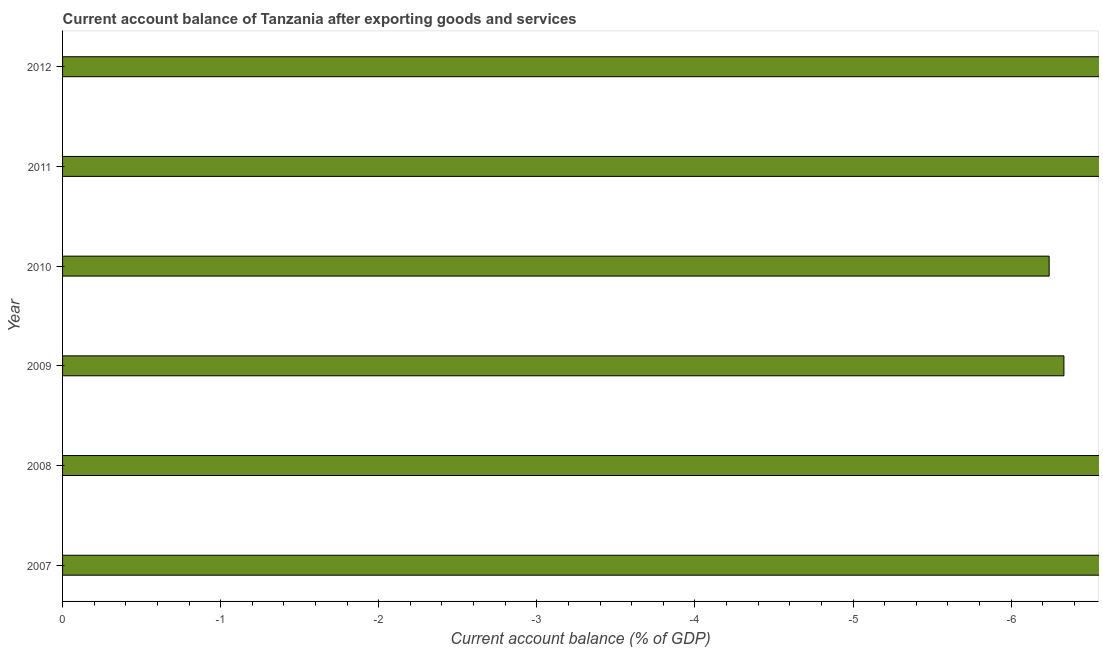Does the graph contain any zero values?
Your answer should be compact. Yes. Does the graph contain grids?
Your answer should be compact. No. What is the title of the graph?
Ensure brevity in your answer.  Current account balance of Tanzania after exporting goods and services. What is the label or title of the X-axis?
Keep it short and to the point. Current account balance (% of GDP). What is the label or title of the Y-axis?
Provide a succinct answer. Year. What is the sum of the current account balance?
Your response must be concise. 0. In how many years, is the current account balance greater than -3.4 %?
Keep it short and to the point. 0. In how many years, is the current account balance greater than the average current account balance taken over all years?
Your answer should be very brief. 0. Are all the bars in the graph horizontal?
Provide a succinct answer. Yes. How many years are there in the graph?
Ensure brevity in your answer.  6. What is the Current account balance (% of GDP) of 2007?
Your answer should be very brief. 0. What is the Current account balance (% of GDP) in 2009?
Ensure brevity in your answer.  0. What is the Current account balance (% of GDP) in 2010?
Ensure brevity in your answer.  0. What is the Current account balance (% of GDP) of 2012?
Provide a short and direct response. 0. 